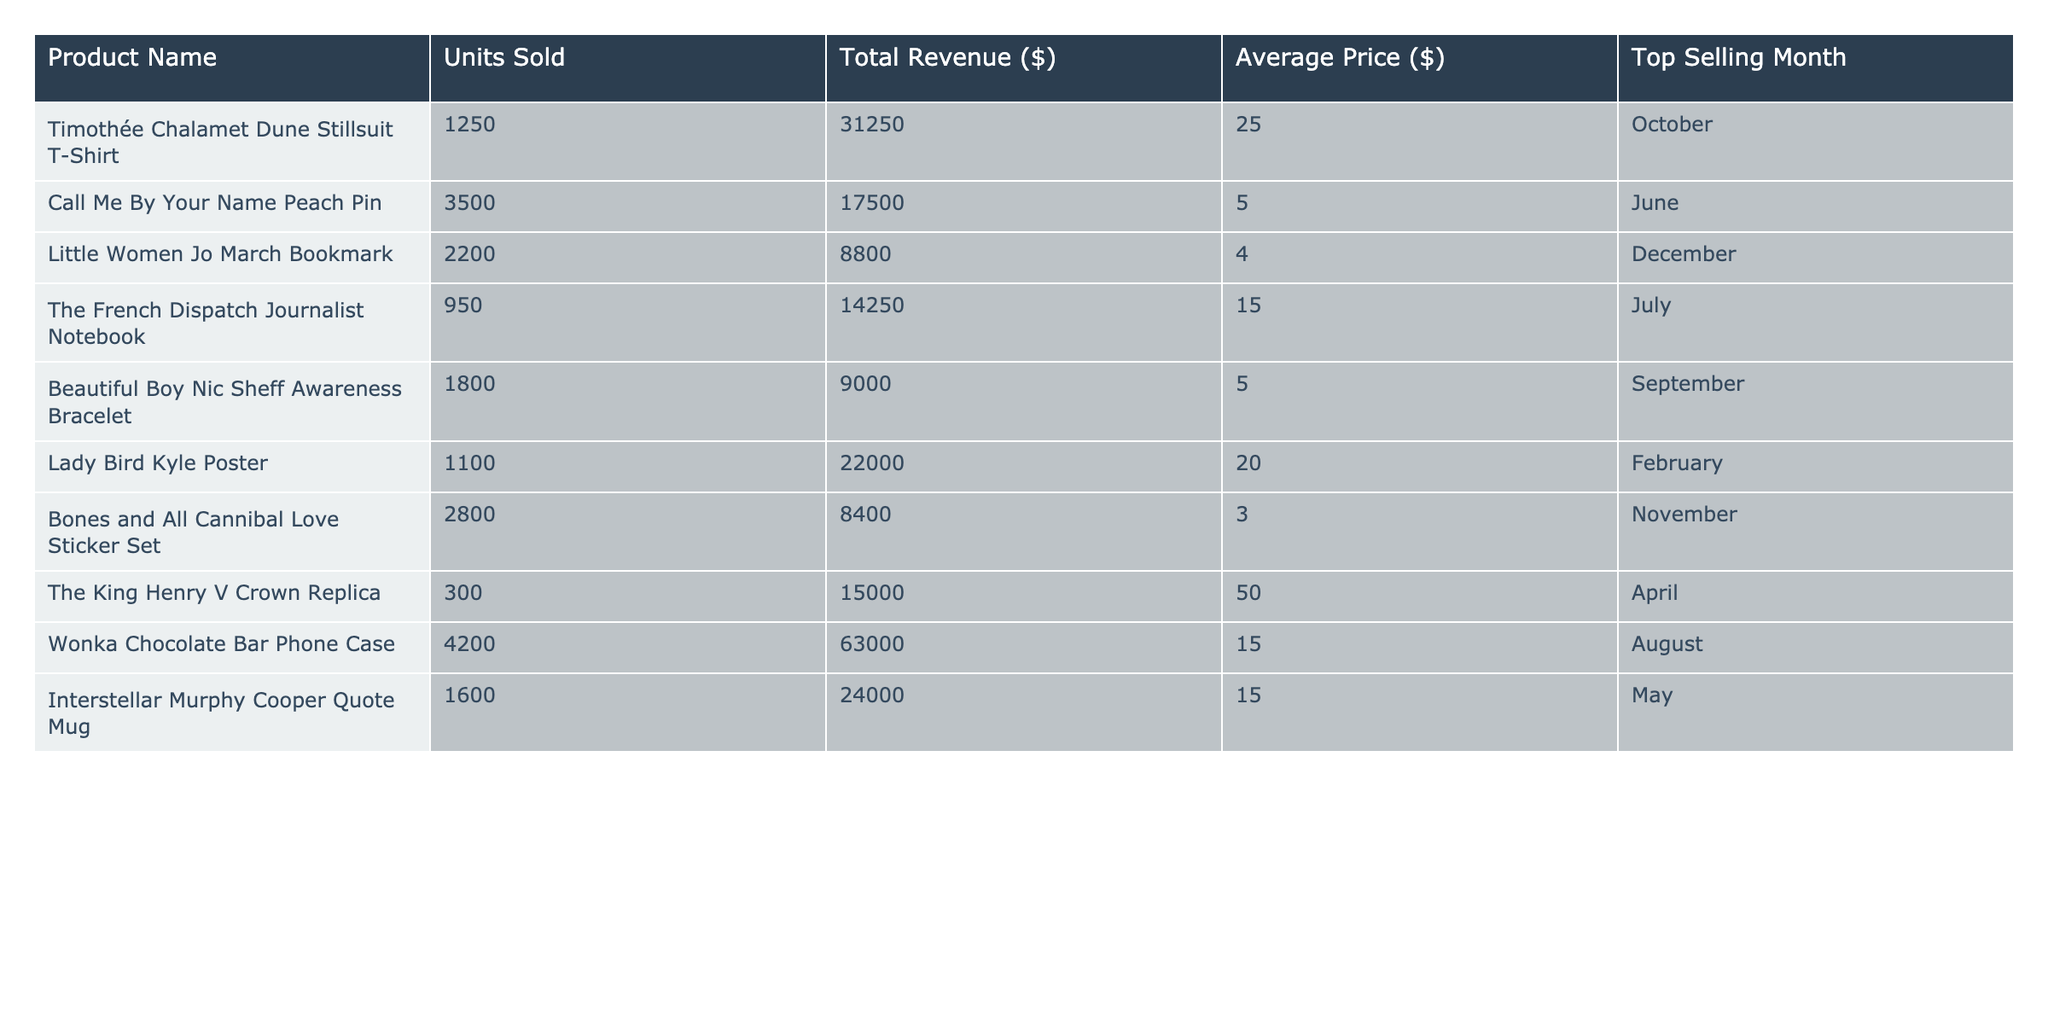What is the total revenue generated from the "Call Me By Your Name Peach Pin"? The revenue for this product is explicitly stated in the table, which shows that "Call Me By Your Name Peach Pin" has generated a total revenue of $17,500.
Answer: $17,500 Which product sold the most units? By reviewing the "Units Sold" column, the product with the highest units sold is the "Call Me By Your Name Peach Pin," which sold 3,500 units.
Answer: "Call Me By Your Name Peach Pin" What is the average price of the "Wonka Chocolate Bar Phone Case"? The average price is provided in the table, clearly listing that the average price of the "Wonka Chocolate Bar Phone Case" is $15.
Answer: $15 How many products have a total revenue exceeding $20,000? By analyzing the total revenue figures, we see that the products meeting this criterion are "Timothée Chalamet Dune Stillsuit T-Shirt," "Lady Bird Kyle Poster," "The King Henry V Crown Replica," and "Wonka Chocolate Bar Phone Case." This results in four products.
Answer: 4 What is the total revenue of products whose average price is below $10? The products with an average price below $10 are "Call Me By Your Name Peach Pin," "Bones and All Cannibal Love Sticker Set," and "Beautiful Boy Nic Sheff Awareness Bracelet." Their respective revenues are $17,500, $8,400, and $9,000, which when summed ($17,500 + $8,400 + $9,000) gives a total revenue of $34,900.
Answer: $34,900 In which month did "Interstellar Murphy Cooper Quote Mug" sell the most? The table indicates that it sold the most in May, as it is listed under the "Top Selling Month" for that product.
Answer: May Is the average price of "The French Dispatch Journalist Notebook" higher than $10? The table shows that the average price for "The French Dispatch Journalist Notebook" is listed as $15, which is indeed greater than $10.
Answer: Yes What is the difference in units sold between the best-selling product and the second-best-selling product? Identifying the top two products in "Units Sold," we find "Call Me By Your Name Peach Pin" with 3,500 units and "Wonka Chocolate Bar Phone Case" with 4,200 units. The difference is calculated as 4,200 - 3,500 = 700.
Answer: 700 Which month was the top-selling period for "Lady Bird Kyle Poster"? The table shows that the top selling month for "Lady Bird Kyle Poster" is February.
Answer: February What is the total number of units sold across all products? To find the total number of units sold, we sum the values in the "Units Sold" column: 1250 (Timothée Chalamet) + 3500 + 2200 + 950 + 1800 + 1100 + 2800 + 300 + 4200 + 1600 = 14,500 units.
Answer: 14,500 How does the average price of "Beautiful Boy Nic Sheff Awareness Bracelet" compare to the overall average price of all products? The average price for "Beautiful Boy Nic Sheff Awareness Bracelet" is $5. The overall average price needs to be calculated by summing up all average prices and dividing by the number of products. Sum = 25 + 5 + 4 + 15 + 5 + 20 + 3 + 50 + 15 = 143, divided by 10 gives an average of $14.3. Since $5 is less than $14.3, the answer is no.
Answer: No 